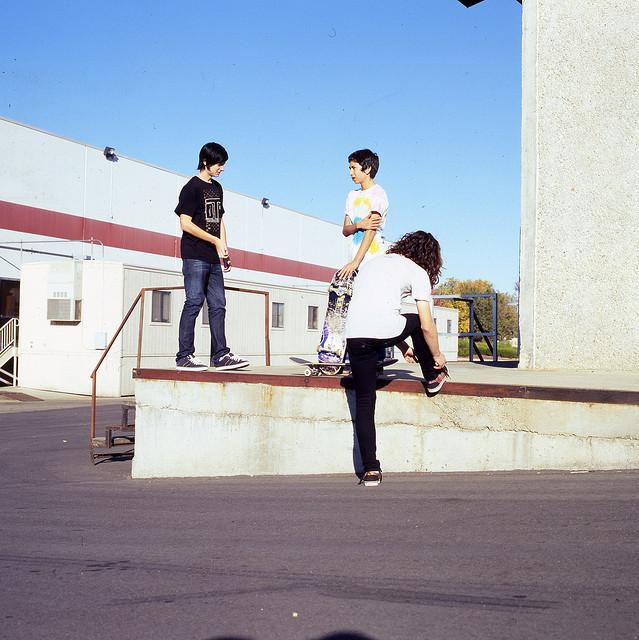Why is the long haired boy touching his shoe?

Choices:
A) scratching itch
B) tying laces
C) undressing
D) stretching tying laces 